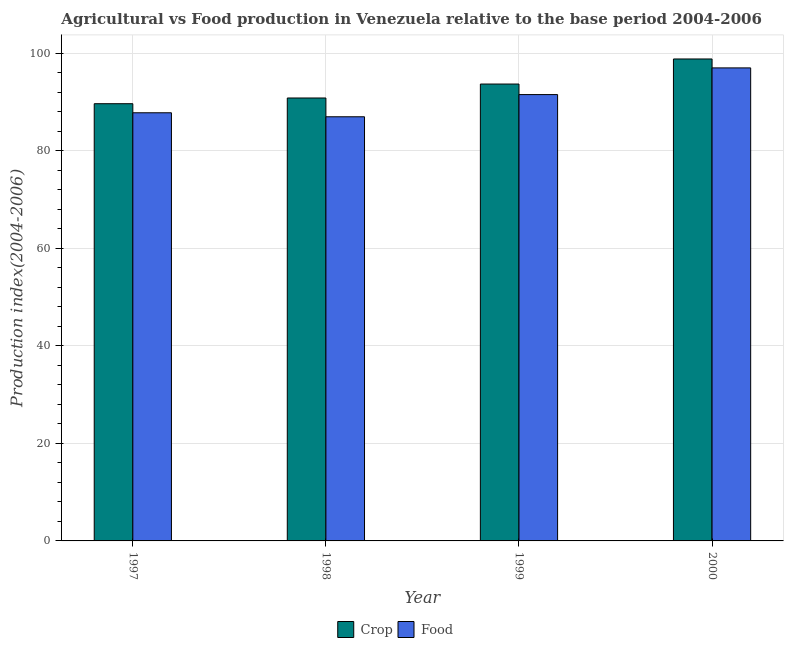Are the number of bars on each tick of the X-axis equal?
Your response must be concise. Yes. How many bars are there on the 4th tick from the right?
Make the answer very short. 2. What is the label of the 2nd group of bars from the left?
Your answer should be very brief. 1998. What is the crop production index in 2000?
Keep it short and to the point. 98.8. Across all years, what is the maximum crop production index?
Make the answer very short. 98.8. Across all years, what is the minimum food production index?
Keep it short and to the point. 86.95. In which year was the food production index maximum?
Offer a very short reply. 2000. What is the total crop production index in the graph?
Ensure brevity in your answer.  372.89. What is the difference between the food production index in 1997 and that in 1999?
Your response must be concise. -3.73. What is the difference between the crop production index in 1997 and the food production index in 1999?
Offer a very short reply. -4.03. What is the average food production index per year?
Ensure brevity in your answer.  90.8. In the year 1999, what is the difference between the crop production index and food production index?
Your answer should be compact. 0. What is the ratio of the crop production index in 1998 to that in 1999?
Ensure brevity in your answer.  0.97. Is the food production index in 1997 less than that in 1999?
Provide a short and direct response. Yes. Is the difference between the food production index in 1997 and 1999 greater than the difference between the crop production index in 1997 and 1999?
Ensure brevity in your answer.  No. What is the difference between the highest and the second highest crop production index?
Keep it short and to the point. 5.14. What is the difference between the highest and the lowest food production index?
Give a very brief answer. 10.02. Is the sum of the food production index in 1998 and 2000 greater than the maximum crop production index across all years?
Your answer should be very brief. Yes. What does the 1st bar from the left in 1997 represents?
Give a very brief answer. Crop. What does the 1st bar from the right in 1999 represents?
Offer a terse response. Food. How many years are there in the graph?
Give a very brief answer. 4. What is the difference between two consecutive major ticks on the Y-axis?
Your answer should be compact. 20. Are the values on the major ticks of Y-axis written in scientific E-notation?
Your answer should be compact. No. Does the graph contain grids?
Provide a short and direct response. Yes. How many legend labels are there?
Your answer should be very brief. 2. How are the legend labels stacked?
Your answer should be very brief. Horizontal. What is the title of the graph?
Make the answer very short. Agricultural vs Food production in Venezuela relative to the base period 2004-2006. What is the label or title of the X-axis?
Make the answer very short. Year. What is the label or title of the Y-axis?
Ensure brevity in your answer.  Production index(2004-2006). What is the Production index(2004-2006) of Crop in 1997?
Provide a short and direct response. 89.63. What is the Production index(2004-2006) of Food in 1997?
Provide a short and direct response. 87.77. What is the Production index(2004-2006) in Crop in 1998?
Keep it short and to the point. 90.8. What is the Production index(2004-2006) of Food in 1998?
Your answer should be compact. 86.95. What is the Production index(2004-2006) in Crop in 1999?
Your answer should be very brief. 93.66. What is the Production index(2004-2006) in Food in 1999?
Provide a short and direct response. 91.5. What is the Production index(2004-2006) in Crop in 2000?
Your answer should be very brief. 98.8. What is the Production index(2004-2006) of Food in 2000?
Make the answer very short. 96.97. Across all years, what is the maximum Production index(2004-2006) of Crop?
Your answer should be compact. 98.8. Across all years, what is the maximum Production index(2004-2006) of Food?
Keep it short and to the point. 96.97. Across all years, what is the minimum Production index(2004-2006) of Crop?
Offer a terse response. 89.63. Across all years, what is the minimum Production index(2004-2006) of Food?
Make the answer very short. 86.95. What is the total Production index(2004-2006) in Crop in the graph?
Your answer should be compact. 372.89. What is the total Production index(2004-2006) in Food in the graph?
Make the answer very short. 363.19. What is the difference between the Production index(2004-2006) in Crop in 1997 and that in 1998?
Your answer should be very brief. -1.17. What is the difference between the Production index(2004-2006) in Food in 1997 and that in 1998?
Keep it short and to the point. 0.82. What is the difference between the Production index(2004-2006) of Crop in 1997 and that in 1999?
Give a very brief answer. -4.03. What is the difference between the Production index(2004-2006) in Food in 1997 and that in 1999?
Give a very brief answer. -3.73. What is the difference between the Production index(2004-2006) of Crop in 1997 and that in 2000?
Provide a short and direct response. -9.17. What is the difference between the Production index(2004-2006) of Food in 1997 and that in 2000?
Offer a very short reply. -9.2. What is the difference between the Production index(2004-2006) of Crop in 1998 and that in 1999?
Provide a succinct answer. -2.86. What is the difference between the Production index(2004-2006) of Food in 1998 and that in 1999?
Ensure brevity in your answer.  -4.55. What is the difference between the Production index(2004-2006) in Food in 1998 and that in 2000?
Your answer should be very brief. -10.02. What is the difference between the Production index(2004-2006) in Crop in 1999 and that in 2000?
Give a very brief answer. -5.14. What is the difference between the Production index(2004-2006) in Food in 1999 and that in 2000?
Ensure brevity in your answer.  -5.47. What is the difference between the Production index(2004-2006) of Crop in 1997 and the Production index(2004-2006) of Food in 1998?
Make the answer very short. 2.68. What is the difference between the Production index(2004-2006) of Crop in 1997 and the Production index(2004-2006) of Food in 1999?
Ensure brevity in your answer.  -1.87. What is the difference between the Production index(2004-2006) of Crop in 1997 and the Production index(2004-2006) of Food in 2000?
Provide a succinct answer. -7.34. What is the difference between the Production index(2004-2006) in Crop in 1998 and the Production index(2004-2006) in Food in 1999?
Provide a short and direct response. -0.7. What is the difference between the Production index(2004-2006) in Crop in 1998 and the Production index(2004-2006) in Food in 2000?
Your answer should be very brief. -6.17. What is the difference between the Production index(2004-2006) of Crop in 1999 and the Production index(2004-2006) of Food in 2000?
Keep it short and to the point. -3.31. What is the average Production index(2004-2006) in Crop per year?
Keep it short and to the point. 93.22. What is the average Production index(2004-2006) in Food per year?
Offer a very short reply. 90.8. In the year 1997, what is the difference between the Production index(2004-2006) of Crop and Production index(2004-2006) of Food?
Your response must be concise. 1.86. In the year 1998, what is the difference between the Production index(2004-2006) in Crop and Production index(2004-2006) in Food?
Your answer should be very brief. 3.85. In the year 1999, what is the difference between the Production index(2004-2006) in Crop and Production index(2004-2006) in Food?
Your answer should be compact. 2.16. In the year 2000, what is the difference between the Production index(2004-2006) of Crop and Production index(2004-2006) of Food?
Provide a short and direct response. 1.83. What is the ratio of the Production index(2004-2006) in Crop in 1997 to that in 1998?
Give a very brief answer. 0.99. What is the ratio of the Production index(2004-2006) in Food in 1997 to that in 1998?
Give a very brief answer. 1.01. What is the ratio of the Production index(2004-2006) of Crop in 1997 to that in 1999?
Your answer should be very brief. 0.96. What is the ratio of the Production index(2004-2006) in Food in 1997 to that in 1999?
Provide a short and direct response. 0.96. What is the ratio of the Production index(2004-2006) of Crop in 1997 to that in 2000?
Make the answer very short. 0.91. What is the ratio of the Production index(2004-2006) of Food in 1997 to that in 2000?
Give a very brief answer. 0.91. What is the ratio of the Production index(2004-2006) of Crop in 1998 to that in 1999?
Offer a terse response. 0.97. What is the ratio of the Production index(2004-2006) in Food in 1998 to that in 1999?
Give a very brief answer. 0.95. What is the ratio of the Production index(2004-2006) of Crop in 1998 to that in 2000?
Offer a terse response. 0.92. What is the ratio of the Production index(2004-2006) in Food in 1998 to that in 2000?
Provide a short and direct response. 0.9. What is the ratio of the Production index(2004-2006) in Crop in 1999 to that in 2000?
Give a very brief answer. 0.95. What is the ratio of the Production index(2004-2006) in Food in 1999 to that in 2000?
Your response must be concise. 0.94. What is the difference between the highest and the second highest Production index(2004-2006) of Crop?
Offer a very short reply. 5.14. What is the difference between the highest and the second highest Production index(2004-2006) of Food?
Provide a succinct answer. 5.47. What is the difference between the highest and the lowest Production index(2004-2006) in Crop?
Your answer should be very brief. 9.17. What is the difference between the highest and the lowest Production index(2004-2006) in Food?
Offer a very short reply. 10.02. 